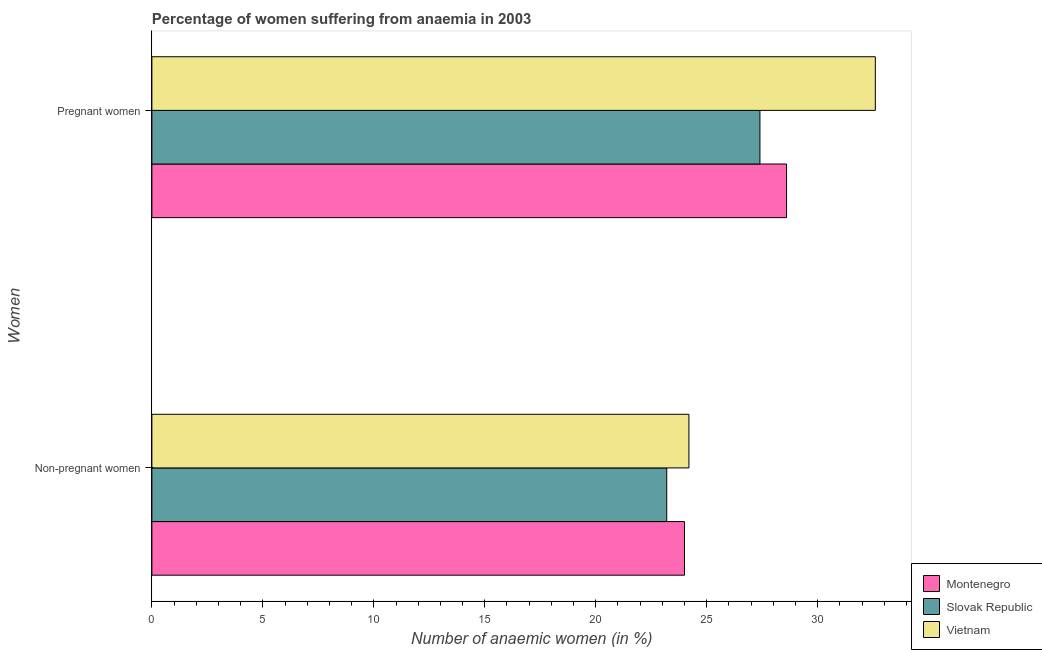How many different coloured bars are there?
Offer a very short reply. 3. How many bars are there on the 1st tick from the top?
Your answer should be very brief. 3. How many bars are there on the 2nd tick from the bottom?
Your answer should be compact. 3. What is the label of the 2nd group of bars from the top?
Your response must be concise. Non-pregnant women. What is the percentage of pregnant anaemic women in Montenegro?
Your response must be concise. 28.6. Across all countries, what is the maximum percentage of pregnant anaemic women?
Keep it short and to the point. 32.6. Across all countries, what is the minimum percentage of pregnant anaemic women?
Keep it short and to the point. 27.4. In which country was the percentage of pregnant anaemic women maximum?
Give a very brief answer. Vietnam. In which country was the percentage of non-pregnant anaemic women minimum?
Give a very brief answer. Slovak Republic. What is the total percentage of non-pregnant anaemic women in the graph?
Ensure brevity in your answer.  71.4. What is the difference between the percentage of pregnant anaemic women in Slovak Republic and the percentage of non-pregnant anaemic women in Vietnam?
Your answer should be very brief. 3.2. What is the average percentage of non-pregnant anaemic women per country?
Provide a succinct answer. 23.8. What is the difference between the percentage of pregnant anaemic women and percentage of non-pregnant anaemic women in Slovak Republic?
Provide a succinct answer. 4.2. In how many countries, is the percentage of non-pregnant anaemic women greater than 14 %?
Offer a very short reply. 3. What is the ratio of the percentage of non-pregnant anaemic women in Slovak Republic to that in Vietnam?
Your response must be concise. 0.96. What does the 2nd bar from the top in Non-pregnant women represents?
Offer a terse response. Slovak Republic. What does the 3rd bar from the bottom in Non-pregnant women represents?
Your answer should be compact. Vietnam. How many bars are there?
Your answer should be very brief. 6. Does the graph contain any zero values?
Provide a succinct answer. No. How are the legend labels stacked?
Offer a very short reply. Vertical. What is the title of the graph?
Provide a succinct answer. Percentage of women suffering from anaemia in 2003. Does "Singapore" appear as one of the legend labels in the graph?
Ensure brevity in your answer.  No. What is the label or title of the X-axis?
Give a very brief answer. Number of anaemic women (in %). What is the label or title of the Y-axis?
Offer a terse response. Women. What is the Number of anaemic women (in %) of Montenegro in Non-pregnant women?
Provide a short and direct response. 24. What is the Number of anaemic women (in %) in Slovak Republic in Non-pregnant women?
Provide a short and direct response. 23.2. What is the Number of anaemic women (in %) of Vietnam in Non-pregnant women?
Your answer should be very brief. 24.2. What is the Number of anaemic women (in %) in Montenegro in Pregnant women?
Offer a terse response. 28.6. What is the Number of anaemic women (in %) of Slovak Republic in Pregnant women?
Offer a terse response. 27.4. What is the Number of anaemic women (in %) in Vietnam in Pregnant women?
Make the answer very short. 32.6. Across all Women, what is the maximum Number of anaemic women (in %) in Montenegro?
Provide a succinct answer. 28.6. Across all Women, what is the maximum Number of anaemic women (in %) of Slovak Republic?
Make the answer very short. 27.4. Across all Women, what is the maximum Number of anaemic women (in %) of Vietnam?
Keep it short and to the point. 32.6. Across all Women, what is the minimum Number of anaemic women (in %) in Slovak Republic?
Make the answer very short. 23.2. Across all Women, what is the minimum Number of anaemic women (in %) of Vietnam?
Your answer should be very brief. 24.2. What is the total Number of anaemic women (in %) in Montenegro in the graph?
Keep it short and to the point. 52.6. What is the total Number of anaemic women (in %) in Slovak Republic in the graph?
Give a very brief answer. 50.6. What is the total Number of anaemic women (in %) in Vietnam in the graph?
Provide a short and direct response. 56.8. What is the difference between the Number of anaemic women (in %) in Montenegro in Non-pregnant women and that in Pregnant women?
Ensure brevity in your answer.  -4.6. What is the difference between the Number of anaemic women (in %) in Montenegro in Non-pregnant women and the Number of anaemic women (in %) in Vietnam in Pregnant women?
Your response must be concise. -8.6. What is the average Number of anaemic women (in %) of Montenegro per Women?
Offer a terse response. 26.3. What is the average Number of anaemic women (in %) in Slovak Republic per Women?
Provide a succinct answer. 25.3. What is the average Number of anaemic women (in %) in Vietnam per Women?
Provide a succinct answer. 28.4. What is the difference between the Number of anaemic women (in %) of Montenegro and Number of anaemic women (in %) of Vietnam in Non-pregnant women?
Make the answer very short. -0.2. What is the difference between the Number of anaemic women (in %) of Slovak Republic and Number of anaemic women (in %) of Vietnam in Non-pregnant women?
Make the answer very short. -1. What is the difference between the Number of anaemic women (in %) in Montenegro and Number of anaemic women (in %) in Vietnam in Pregnant women?
Keep it short and to the point. -4. What is the ratio of the Number of anaemic women (in %) of Montenegro in Non-pregnant women to that in Pregnant women?
Offer a terse response. 0.84. What is the ratio of the Number of anaemic women (in %) in Slovak Republic in Non-pregnant women to that in Pregnant women?
Your answer should be compact. 0.85. What is the ratio of the Number of anaemic women (in %) in Vietnam in Non-pregnant women to that in Pregnant women?
Offer a very short reply. 0.74. What is the difference between the highest and the second highest Number of anaemic women (in %) in Slovak Republic?
Offer a terse response. 4.2. What is the difference between the highest and the lowest Number of anaemic women (in %) in Slovak Republic?
Provide a succinct answer. 4.2. 